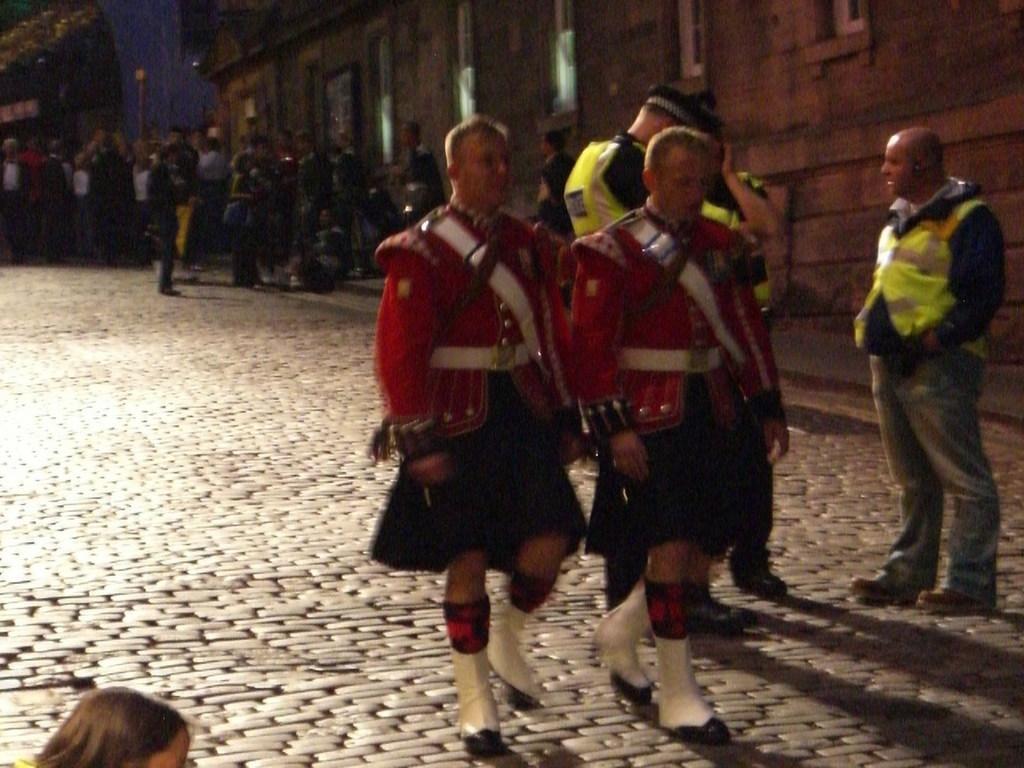Could you give a brief overview of what you see in this image? In this Image I can see the group of people with different color dresses. These people are on the road. To the side of these I can see the building with windows. 